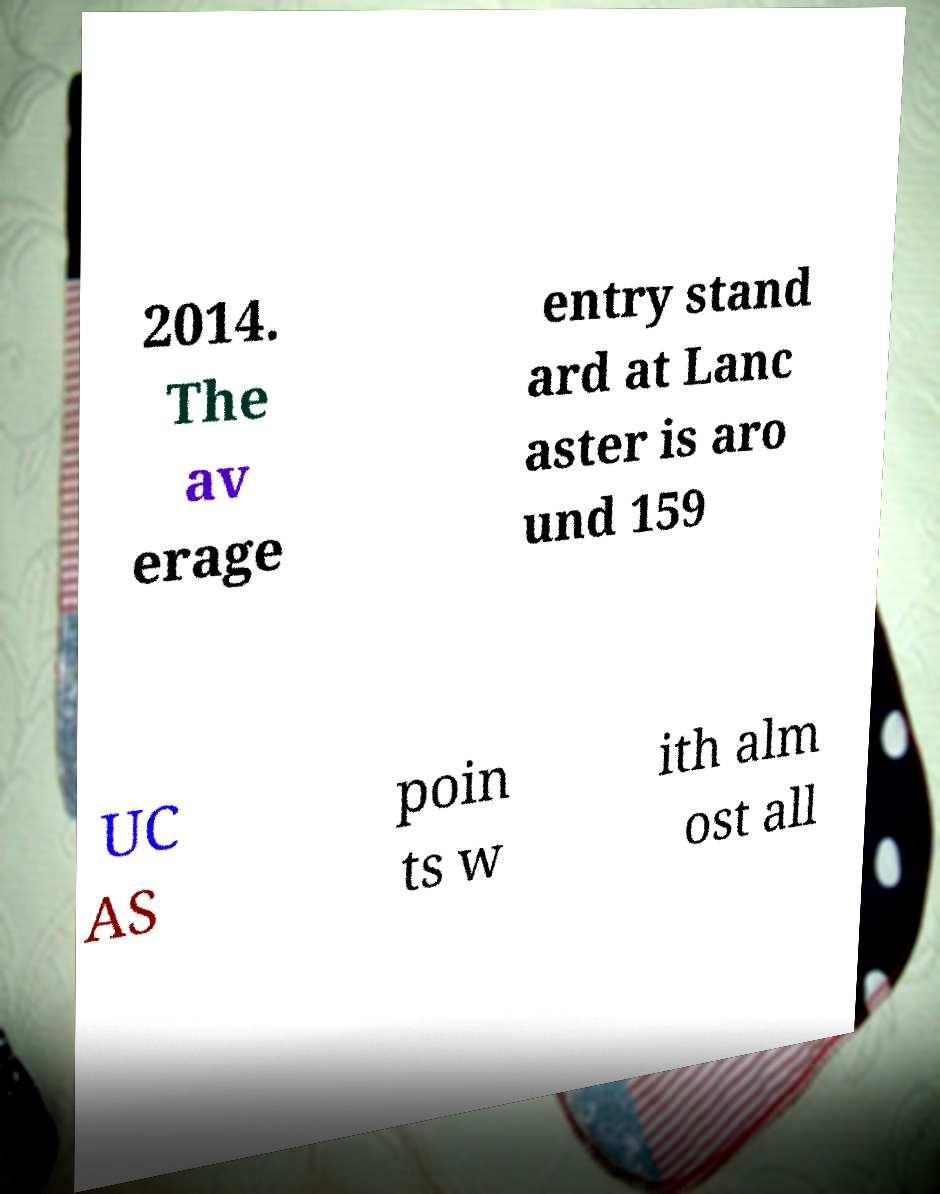Could you assist in decoding the text presented in this image and type it out clearly? 2014. The av erage entry stand ard at Lanc aster is aro und 159 UC AS poin ts w ith alm ost all 